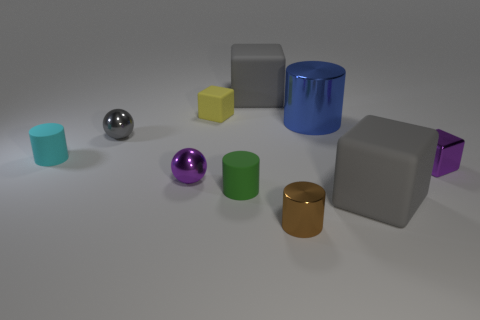Subtract all gray cylinders. How many gray cubes are left? 2 Subtract all tiny metal blocks. How many blocks are left? 3 Subtract all purple cubes. How many cubes are left? 3 Subtract all red cubes. Subtract all gray cylinders. How many cubes are left? 4 Subtract all cubes. How many objects are left? 6 Add 5 cyan shiny objects. How many cyan shiny objects exist? 5 Subtract 1 cyan cylinders. How many objects are left? 9 Subtract all small gray matte cubes. Subtract all large rubber cubes. How many objects are left? 8 Add 6 small yellow rubber blocks. How many small yellow rubber blocks are left? 7 